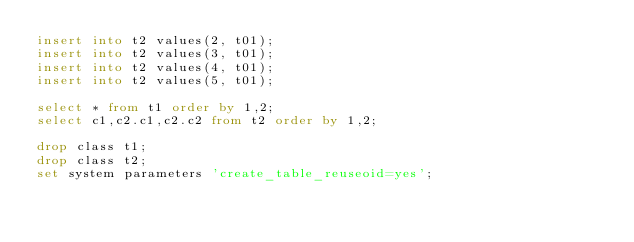<code> <loc_0><loc_0><loc_500><loc_500><_SQL_>insert into t2 values(2, t01);
insert into t2 values(3, t01);
insert into t2 values(4, t01);
insert into t2 values(5, t01);

select * from t1 order by 1,2;
select c1,c2.c1,c2.c2 from t2 order by 1,2;

drop class t1;
drop class t2;
set system parameters 'create_table_reuseoid=yes';

</code> 